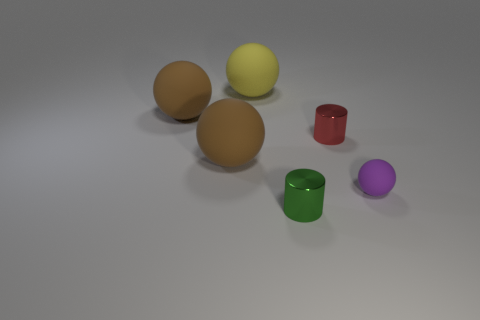What number of things are both in front of the large yellow thing and on the left side of the tiny purple rubber sphere?
Offer a terse response. 4. What number of metal things are small things or cylinders?
Provide a short and direct response. 2. There is a sphere that is to the right of the small metallic cylinder that is right of the green metallic object; what is its size?
Give a very brief answer. Small. There is a small metal thing that is to the left of the tiny metal cylinder behind the green metallic object; is there a rubber ball that is to the left of it?
Offer a very short reply. Yes. Is the material of the small purple thing that is behind the green cylinder the same as the brown thing that is in front of the red metal object?
Provide a succinct answer. Yes. How many things are either tiny green matte things or big matte spheres that are on the left side of the big yellow rubber object?
Offer a terse response. 2. What number of green metal objects have the same shape as the tiny purple matte thing?
Offer a very short reply. 0. There is a purple thing that is the same size as the red thing; what is it made of?
Give a very brief answer. Rubber. How big is the cylinder in front of the tiny purple ball that is behind the metal cylinder in front of the tiny purple rubber thing?
Your answer should be very brief. Small. Is the color of the big rubber ball that is in front of the red shiny object the same as the small thing behind the small purple sphere?
Keep it short and to the point. No. 